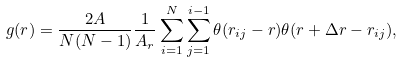<formula> <loc_0><loc_0><loc_500><loc_500>g ( r ) = \frac { 2 A } { N ( N - 1 ) } \frac { 1 } { A _ { r } } \sum _ { i = 1 } ^ { N } \sum _ { j = 1 } ^ { i - 1 } \theta ( r _ { i j } - r ) \theta ( r + \Delta r - r _ { i j } ) ,</formula> 